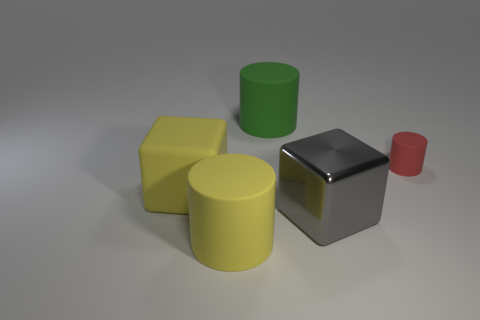Subtract all small red cylinders. How many cylinders are left? 2 Add 2 green rubber things. How many objects exist? 7 Subtract all yellow cylinders. How many cylinders are left? 2 Subtract all blocks. How many objects are left? 3 Subtract 1 cubes. How many cubes are left? 1 Subtract 0 purple spheres. How many objects are left? 5 Subtract all yellow cubes. Subtract all yellow spheres. How many cubes are left? 1 Subtract all brown cylinders. How many purple blocks are left? 0 Subtract all red rubber cylinders. Subtract all large objects. How many objects are left? 0 Add 5 red objects. How many red objects are left? 6 